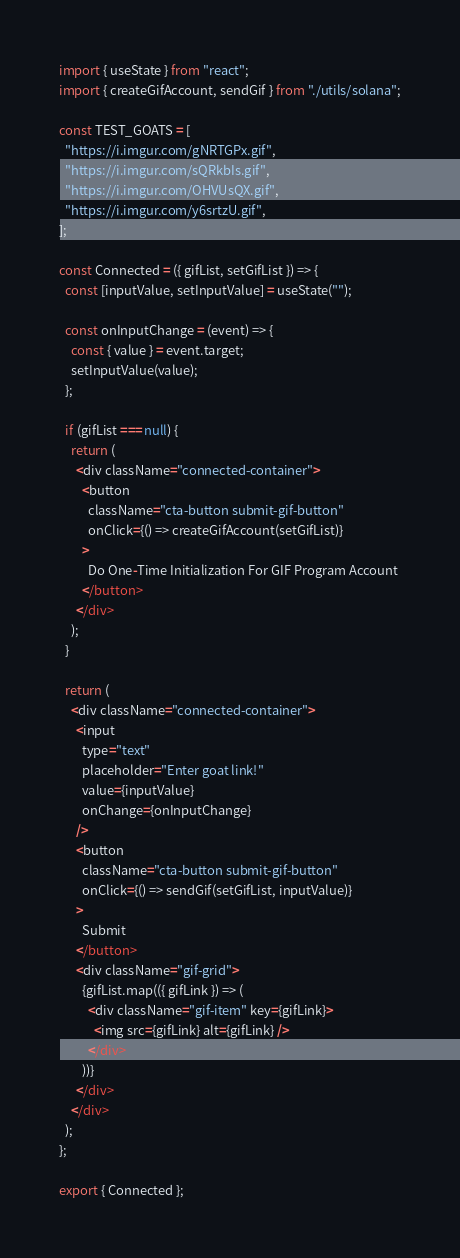Convert code to text. <code><loc_0><loc_0><loc_500><loc_500><_JavaScript_>import { useState } from "react";
import { createGifAccount, sendGif } from "./utils/solana";

const TEST_GOATS = [
  "https://i.imgur.com/gNRTGPx.gif",
  "https://i.imgur.com/sQRkbIs.gif",
  "https://i.imgur.com/OHVUsQX.gif",
  "https://i.imgur.com/y6srtzU.gif",
];

const Connected = ({ gifList, setGifList }) => {
  const [inputValue, setInputValue] = useState("");

  const onInputChange = (event) => {
    const { value } = event.target;
    setInputValue(value);
  };

  if (gifList === null) {
    return (
      <div className="connected-container">
        <button
          className="cta-button submit-gif-button"
          onClick={() => createGifAccount(setGifList)}
        >
          Do One-Time Initialization For GIF Program Account
        </button>
      </div>
    );
  }

  return (
    <div className="connected-container">
      <input
        type="text"
        placeholder="Enter goat link!"
        value={inputValue}
        onChange={onInputChange}
      />
      <button
        className="cta-button submit-gif-button"
        onClick={() => sendGif(setGifList, inputValue)}
      >
        Submit
      </button>
      <div className="gif-grid">
        {gifList.map(({ gifLink }) => (
          <div className="gif-item" key={gifLink}>
            <img src={gifLink} alt={gifLink} />
          </div>
        ))}
      </div>
    </div>
  );
};

export { Connected };
</code> 